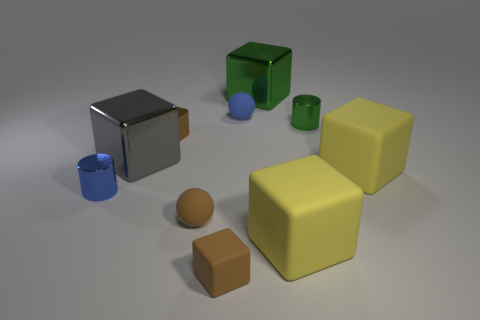What material is the cylinder that is to the left of the block that is behind the green thing in front of the blue matte ball?
Provide a succinct answer. Metal. Does the tiny matte cube have the same color as the big thing behind the large gray object?
Offer a terse response. No. Are there any other things that have the same shape as the tiny blue metal thing?
Provide a succinct answer. Yes. The tiny sphere that is to the left of the ball behind the big gray shiny block is what color?
Offer a very short reply. Brown. What number of purple cylinders are there?
Give a very brief answer. 0. What number of metallic objects are either brown balls or small green things?
Provide a short and direct response. 1. What number of large cubes have the same color as the tiny rubber cube?
Provide a succinct answer. 0. The large thing to the left of the small matte thing that is behind the small shiny block is made of what material?
Give a very brief answer. Metal. The brown metallic block has what size?
Provide a short and direct response. Small. How many gray objects are the same size as the green cube?
Ensure brevity in your answer.  1. 